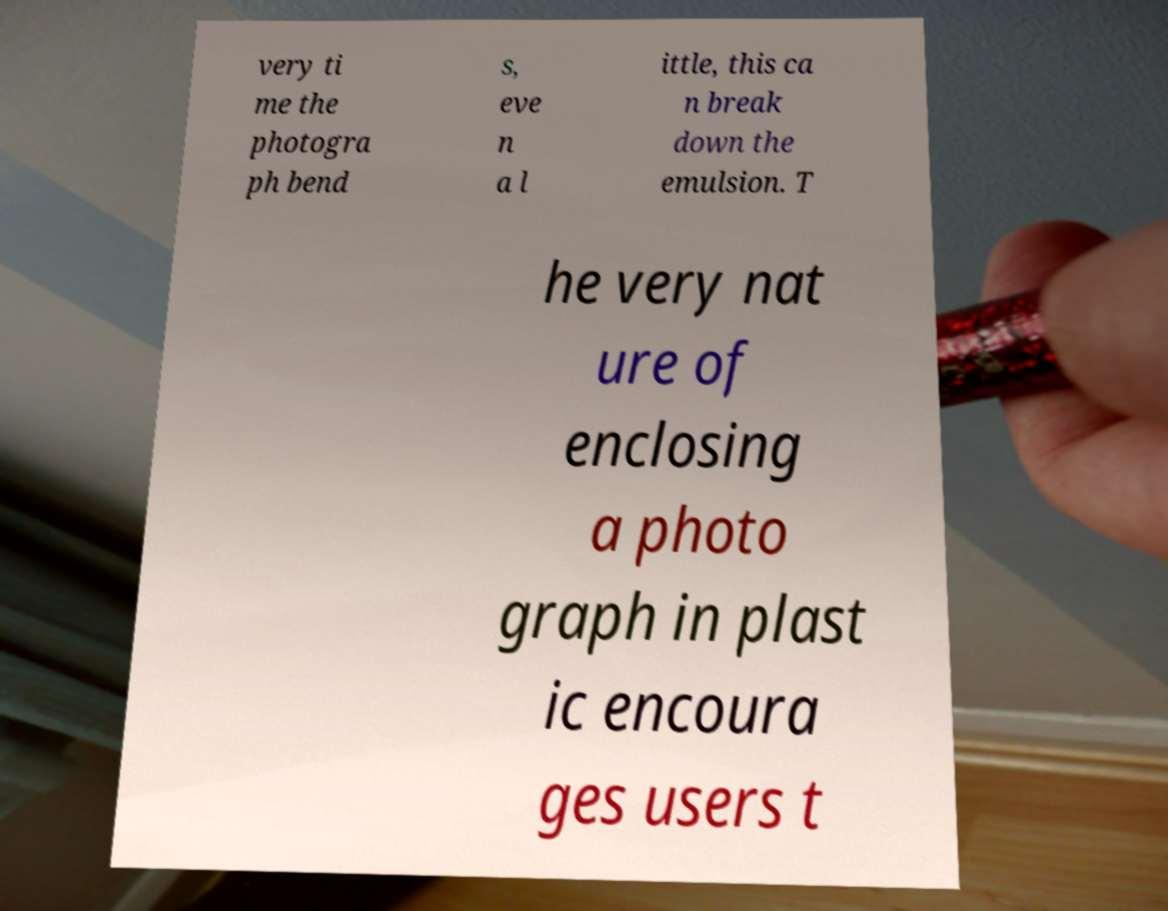Can you accurately transcribe the text from the provided image for me? very ti me the photogra ph bend s, eve n a l ittle, this ca n break down the emulsion. T he very nat ure of enclosing a photo graph in plast ic encoura ges users t 